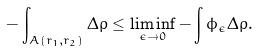Convert formula to latex. <formula><loc_0><loc_0><loc_500><loc_500>- \int _ { A ( r _ { 1 } , r _ { 2 } ) } \Delta \rho \leq \liminf _ { \epsilon \rightarrow 0 } - \int \phi _ { \epsilon } \Delta \rho .</formula> 